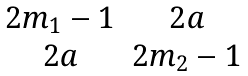<formula> <loc_0><loc_0><loc_500><loc_500>\begin{matrix} 2 m _ { 1 } - 1 & 2 a \\ 2 a & 2 m _ { 2 } - 1 \end{matrix}</formula> 